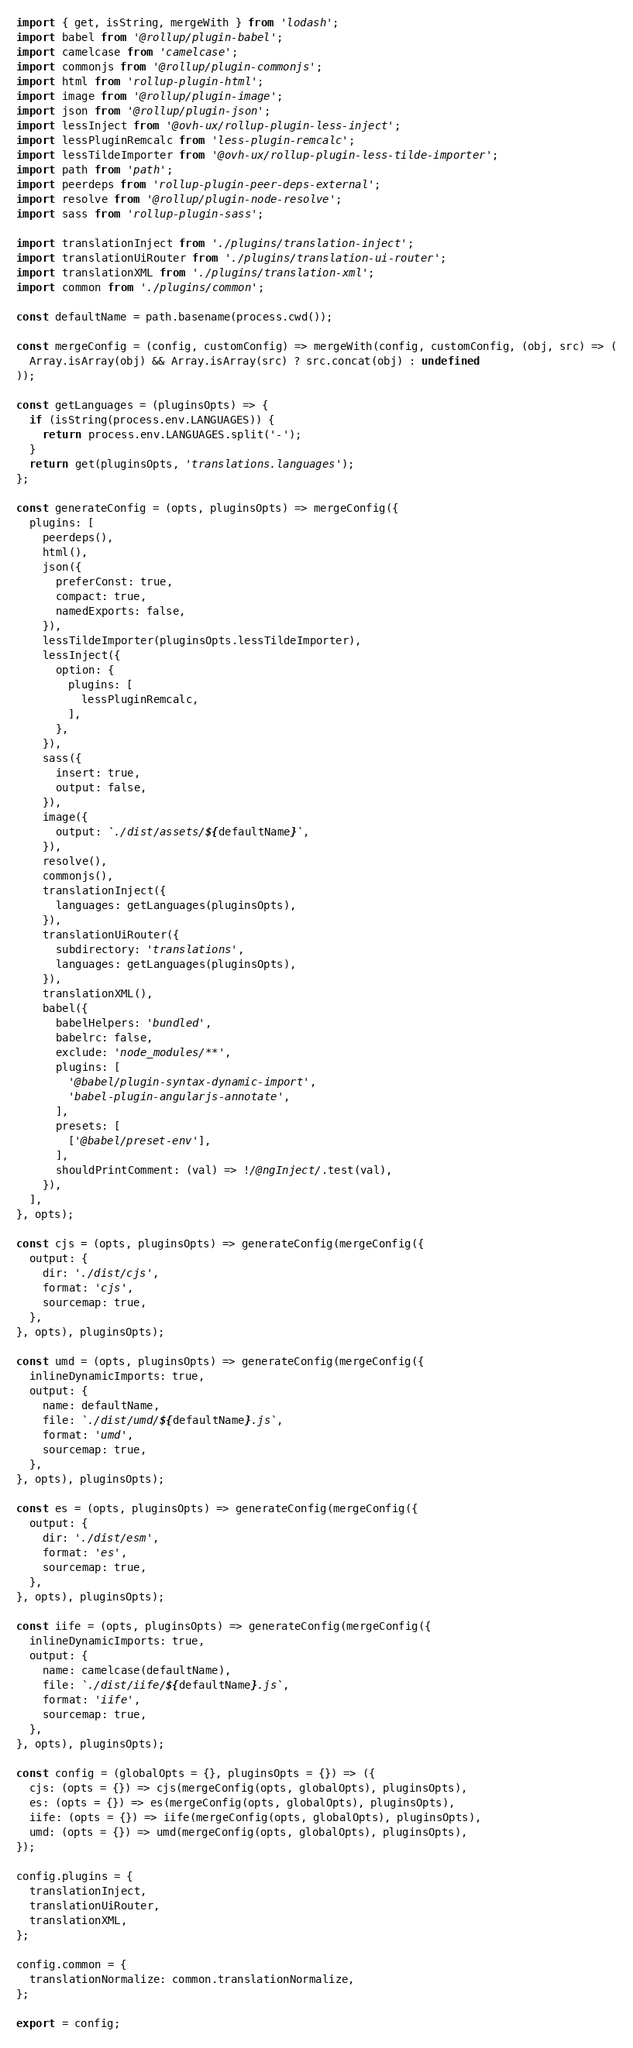<code> <loc_0><loc_0><loc_500><loc_500><_TypeScript_>import { get, isString, mergeWith } from 'lodash';
import babel from '@rollup/plugin-babel';
import camelcase from 'camelcase';
import commonjs from '@rollup/plugin-commonjs';
import html from 'rollup-plugin-html';
import image from '@rollup/plugin-image';
import json from '@rollup/plugin-json';
import lessInject from '@ovh-ux/rollup-plugin-less-inject';
import lessPluginRemcalc from 'less-plugin-remcalc';
import lessTildeImporter from '@ovh-ux/rollup-plugin-less-tilde-importer';
import path from 'path';
import peerdeps from 'rollup-plugin-peer-deps-external';
import resolve from '@rollup/plugin-node-resolve';
import sass from 'rollup-plugin-sass';

import translationInject from './plugins/translation-inject';
import translationUiRouter from './plugins/translation-ui-router';
import translationXML from './plugins/translation-xml';
import common from './plugins/common';

const defaultName = path.basename(process.cwd());

const mergeConfig = (config, customConfig) => mergeWith(config, customConfig, (obj, src) => (
  Array.isArray(obj) && Array.isArray(src) ? src.concat(obj) : undefined
));

const getLanguages = (pluginsOpts) => {
  if (isString(process.env.LANGUAGES)) {
    return process.env.LANGUAGES.split('-');
  }
  return get(pluginsOpts, 'translations.languages');
};

const generateConfig = (opts, pluginsOpts) => mergeConfig({
  plugins: [
    peerdeps(),
    html(),
    json({
      preferConst: true,
      compact: true,
      namedExports: false,
    }),
    lessTildeImporter(pluginsOpts.lessTildeImporter),
    lessInject({
      option: {
        plugins: [
          lessPluginRemcalc,
        ],
      },
    }),
    sass({
      insert: true,
      output: false,
    }),
    image({
      output: `./dist/assets/${defaultName}`,
    }),
    resolve(),
    commonjs(),
    translationInject({
      languages: getLanguages(pluginsOpts),
    }),
    translationUiRouter({
      subdirectory: 'translations',
      languages: getLanguages(pluginsOpts),
    }),
    translationXML(),
    babel({
      babelHelpers: 'bundled',
      babelrc: false,
      exclude: 'node_modules/**',
      plugins: [
        '@babel/plugin-syntax-dynamic-import',
        'babel-plugin-angularjs-annotate',
      ],
      presets: [
        ['@babel/preset-env'],
      ],
      shouldPrintComment: (val) => !/@ngInject/.test(val),
    }),
  ],
}, opts);

const cjs = (opts, pluginsOpts) => generateConfig(mergeConfig({
  output: {
    dir: './dist/cjs',
    format: 'cjs',
    sourcemap: true,
  },
}, opts), pluginsOpts);

const umd = (opts, pluginsOpts) => generateConfig(mergeConfig({
  inlineDynamicImports: true,
  output: {
    name: defaultName,
    file: `./dist/umd/${defaultName}.js`,
    format: 'umd',
    sourcemap: true,
  },
}, opts), pluginsOpts);

const es = (opts, pluginsOpts) => generateConfig(mergeConfig({
  output: {
    dir: './dist/esm',
    format: 'es',
    sourcemap: true,
  },
}, opts), pluginsOpts);

const iife = (opts, pluginsOpts) => generateConfig(mergeConfig({
  inlineDynamicImports: true,
  output: {
    name: camelcase(defaultName),
    file: `./dist/iife/${defaultName}.js`,
    format: 'iife',
    sourcemap: true,
  },
}, opts), pluginsOpts);

const config = (globalOpts = {}, pluginsOpts = {}) => ({
  cjs: (opts = {}) => cjs(mergeConfig(opts, globalOpts), pluginsOpts),
  es: (opts = {}) => es(mergeConfig(opts, globalOpts), pluginsOpts),
  iife: (opts = {}) => iife(mergeConfig(opts, globalOpts), pluginsOpts),
  umd: (opts = {}) => umd(mergeConfig(opts, globalOpts), pluginsOpts),
});

config.plugins = {
  translationInject,
  translationUiRouter,
  translationXML,
};

config.common = {
  translationNormalize: common.translationNormalize,
};

export = config;
</code> 